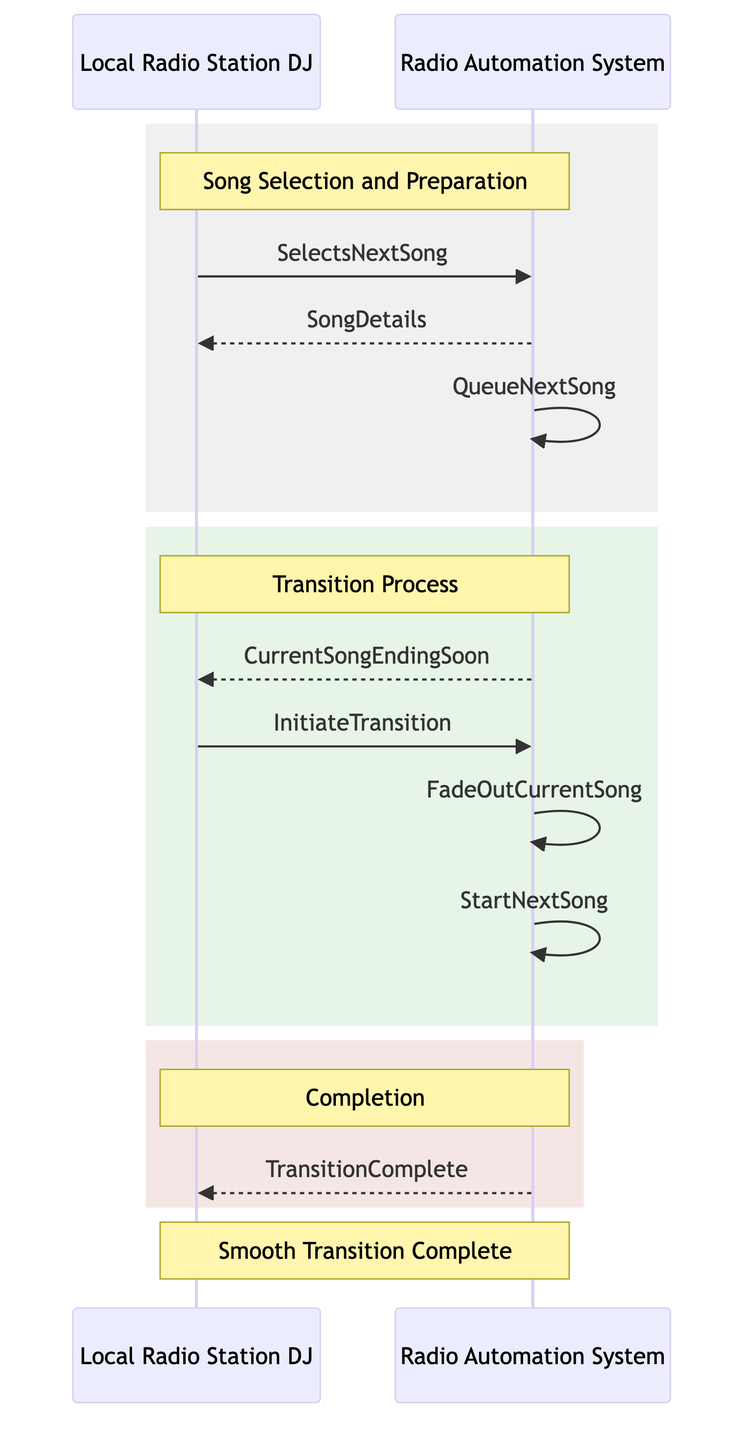What's the first message in the sequence? The first message in the sequence is sent from the DJ to the Radio Automation System, which is "SelectsNextSong." This can be identified as it is the first arrow pointing from DJ to RAS in the "Song Selection and Preparation" section of the diagram.
Answer: SelectsNextSong How many messages are exchanged between the DJ and the Radio Automation System? There are a total of seven messages exchanged in the diagram. By counting all arrows between DJ and RAS, we can identify that there are four messages from DJ and three from RAS, totaling seven.
Answer: Seven What action does the Radio Automation System take after sending the "CurrentSongEndingSoon" message? After sending the "CurrentSongEndingSoon" message to the DJ, the Radio Automation System initiates the transition process by receiving the "InitiateTransition" message from the DJ, which represents the starting of that action.
Answer: InitiateTransition What is the last message sent in the sequence? The last message sent in the sequence is "TransitionComplete," which is sent from the Radio Automation System to the DJ. It indicates the final step in the transition process.
Answer: TransitionComplete What is the purpose of the "QueueNextSong" action? The "QueueNextSong" action is used by the Radio Automation System to prepare for a smooth transition by placing the next song in a queue after the DJ selects it. This ensures that the next song will be ready when the transition is initiated.
Answer: To prepare for a smooth transition How many distinct roles are represented in the diagram? The diagram includes two distinct roles as represented by the participants: the DJ and the Radio Automation System. No other roles are present in the sequence.
Answer: Two What happens after the "FadeOutCurrentSong" message? After the "FadeOutCurrentSong" message is processed by the Radio Automation System, it proceeds to execute the "StartNextSong" message. This represents the continuation of the transition to ensure the next song begins to play.
Answer: StartNextSong What does the DJ receive immediately after selecting the next song? Immediately after selecting the next song, the DJ receives the "SongDetails" from the Radio Automation System. This message provides information about the song selected.
Answer: SongDetails 